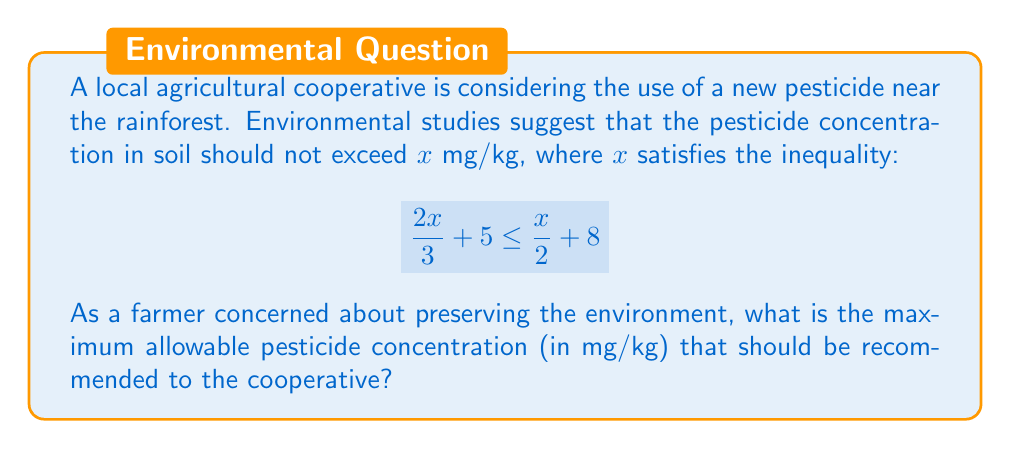Show me your answer to this math problem. Let's solve this step-by-step:

1) Start with the given inequality:
   $$\frac{2x}{3} + 5 \leq \frac{x}{2} + 8$$

2) Multiply both sides by 6 to eliminate fractions:
   $$6 \cdot (\frac{2x}{3} + 5) \leq 6 \cdot (\frac{x}{2} + 8)$$
   $$(4x + 30) \leq (3x + 48)$$

3) Subtract 3x from both sides:
   $$x + 30 \leq 48$$

4) Subtract 30 from both sides:
   $$x \leq 18$$

5) Therefore, the maximum value of x is 18 mg/kg.

This means that to prevent environmental damage, the pesticide concentration in the soil should not exceed 18 mg/kg.
Answer: 18 mg/kg 